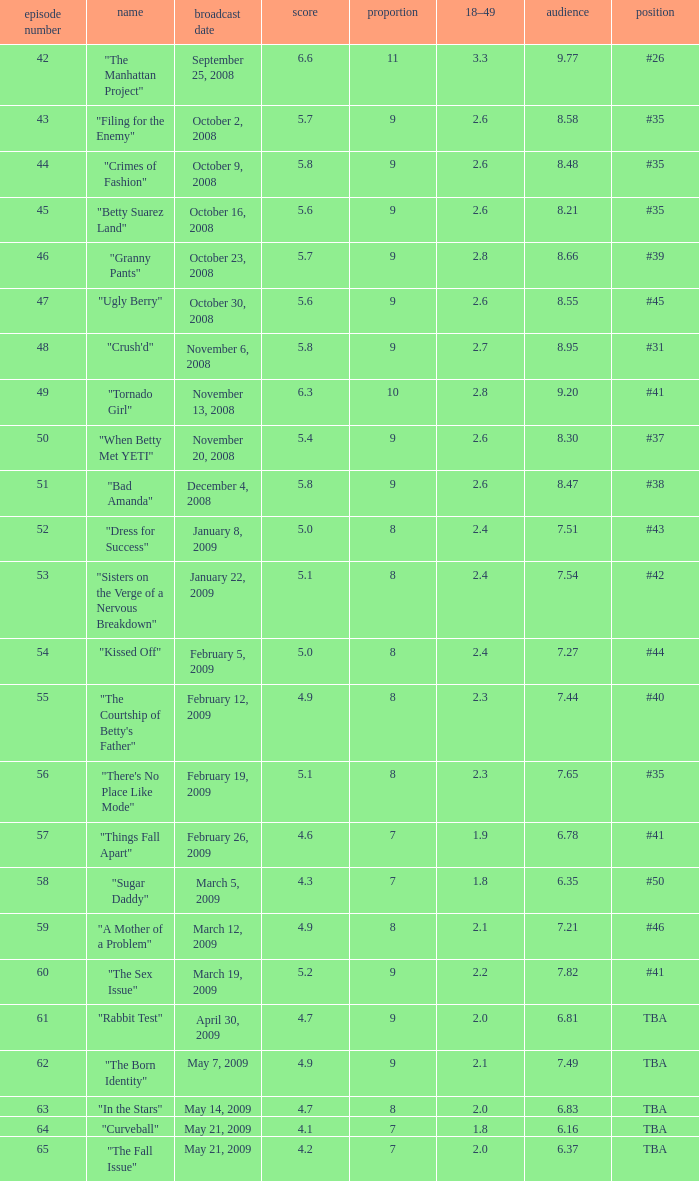What is the total number of Viewers when the rank is #40? 1.0. 